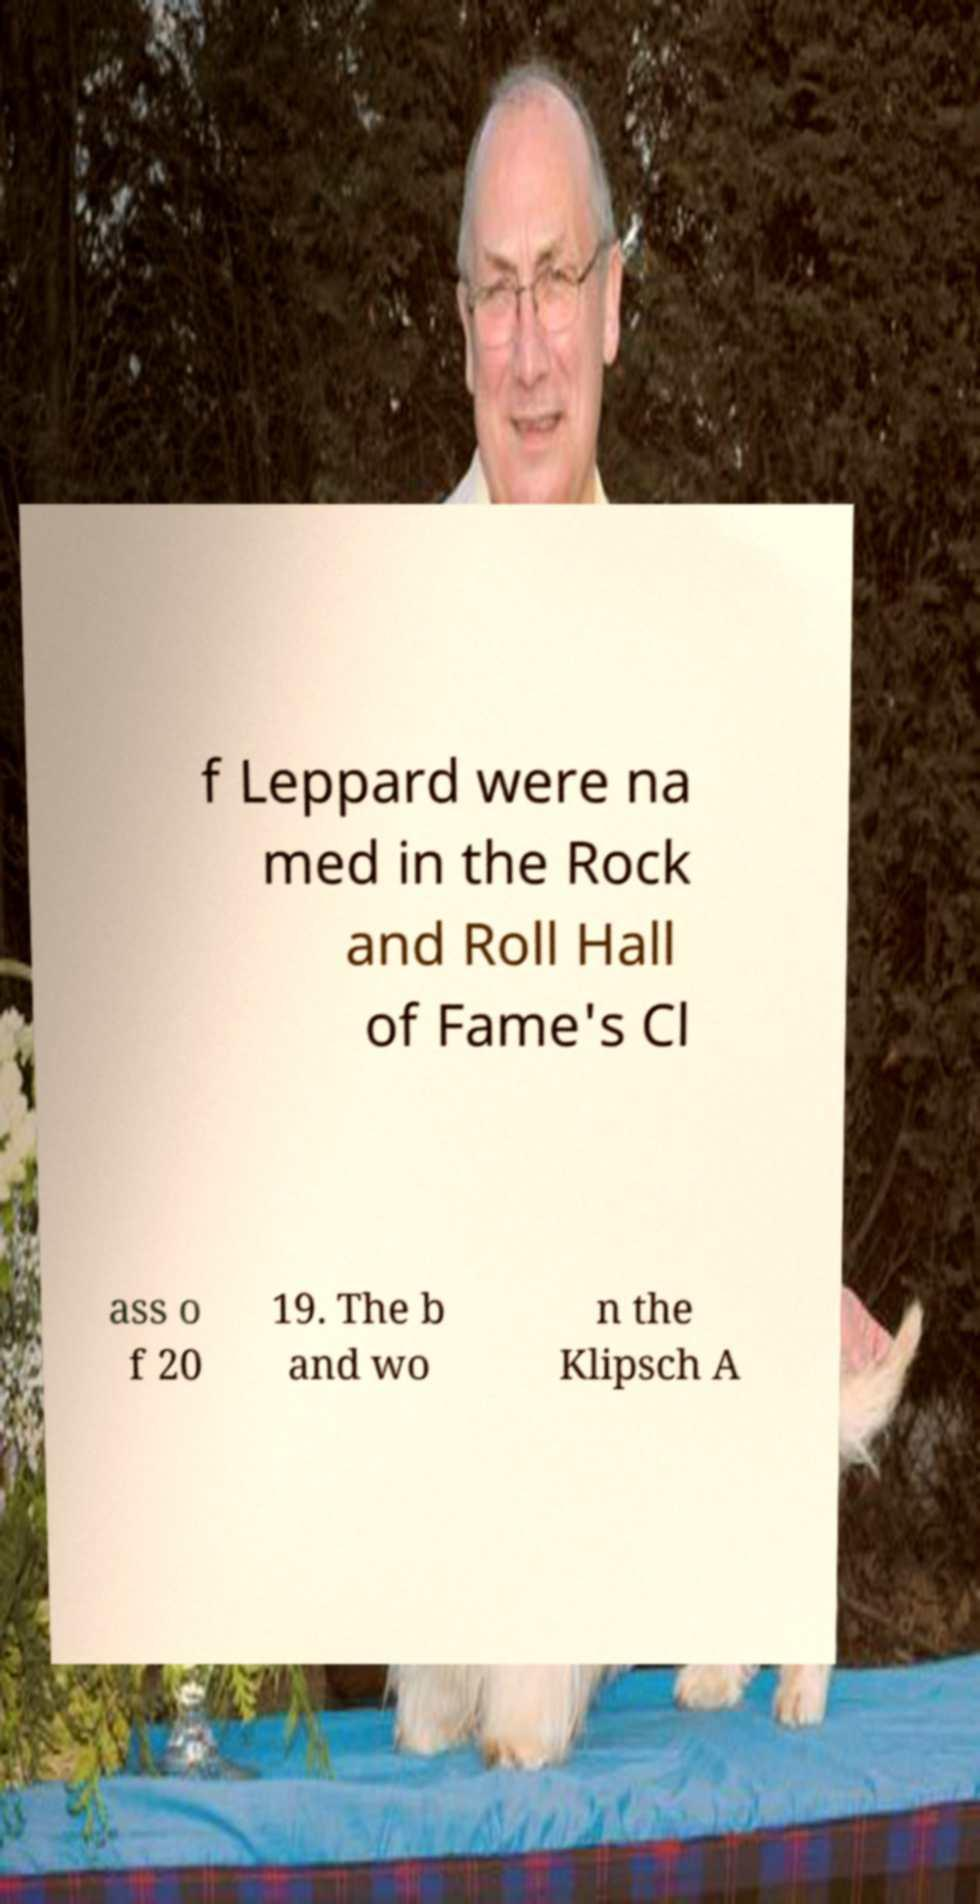Please identify and transcribe the text found in this image. f Leppard were na med in the Rock and Roll Hall of Fame's Cl ass o f 20 19. The b and wo n the Klipsch A 